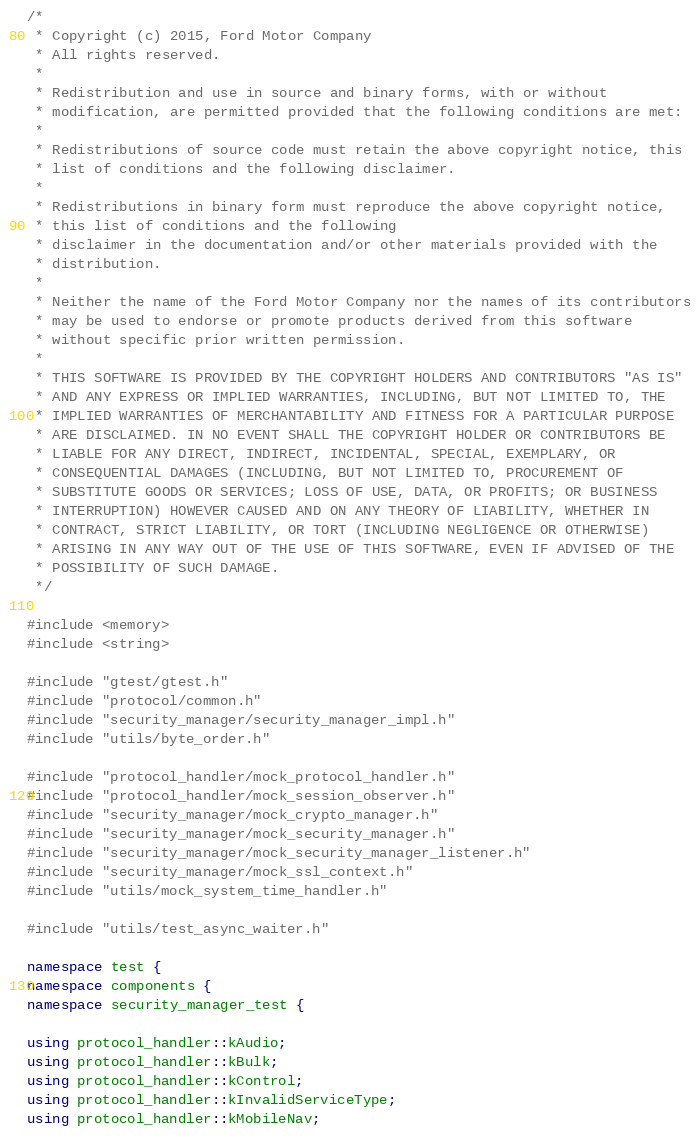<code> <loc_0><loc_0><loc_500><loc_500><_C++_>/*
 * Copyright (c) 2015, Ford Motor Company
 * All rights reserved.
 *
 * Redistribution and use in source and binary forms, with or without
 * modification, are permitted provided that the following conditions are met:
 *
 * Redistributions of source code must retain the above copyright notice, this
 * list of conditions and the following disclaimer.
 *
 * Redistributions in binary form must reproduce the above copyright notice,
 * this list of conditions and the following
 * disclaimer in the documentation and/or other materials provided with the
 * distribution.
 *
 * Neither the name of the Ford Motor Company nor the names of its contributors
 * may be used to endorse or promote products derived from this software
 * without specific prior written permission.
 *
 * THIS SOFTWARE IS PROVIDED BY THE COPYRIGHT HOLDERS AND CONTRIBUTORS "AS IS"
 * AND ANY EXPRESS OR IMPLIED WARRANTIES, INCLUDING, BUT NOT LIMITED TO, THE
 * IMPLIED WARRANTIES OF MERCHANTABILITY AND FITNESS FOR A PARTICULAR PURPOSE
 * ARE DISCLAIMED. IN NO EVENT SHALL THE COPYRIGHT HOLDER OR CONTRIBUTORS BE
 * LIABLE FOR ANY DIRECT, INDIRECT, INCIDENTAL, SPECIAL, EXEMPLARY, OR
 * CONSEQUENTIAL DAMAGES (INCLUDING, BUT NOT LIMITED TO, PROCUREMENT OF
 * SUBSTITUTE GOODS OR SERVICES; LOSS OF USE, DATA, OR PROFITS; OR BUSINESS
 * INTERRUPTION) HOWEVER CAUSED AND ON ANY THEORY OF LIABILITY, WHETHER IN
 * CONTRACT, STRICT LIABILITY, OR TORT (INCLUDING NEGLIGENCE OR OTHERWISE)
 * ARISING IN ANY WAY OUT OF THE USE OF THIS SOFTWARE, EVEN IF ADVISED OF THE
 * POSSIBILITY OF SUCH DAMAGE.
 */

#include <memory>
#include <string>

#include "gtest/gtest.h"
#include "protocol/common.h"
#include "security_manager/security_manager_impl.h"
#include "utils/byte_order.h"

#include "protocol_handler/mock_protocol_handler.h"
#include "protocol_handler/mock_session_observer.h"
#include "security_manager/mock_crypto_manager.h"
#include "security_manager/mock_security_manager.h"
#include "security_manager/mock_security_manager_listener.h"
#include "security_manager/mock_ssl_context.h"
#include "utils/mock_system_time_handler.h"

#include "utils/test_async_waiter.h"

namespace test {
namespace components {
namespace security_manager_test {

using protocol_handler::kAudio;
using protocol_handler::kBulk;
using protocol_handler::kControl;
using protocol_handler::kInvalidServiceType;
using protocol_handler::kMobileNav;</code> 